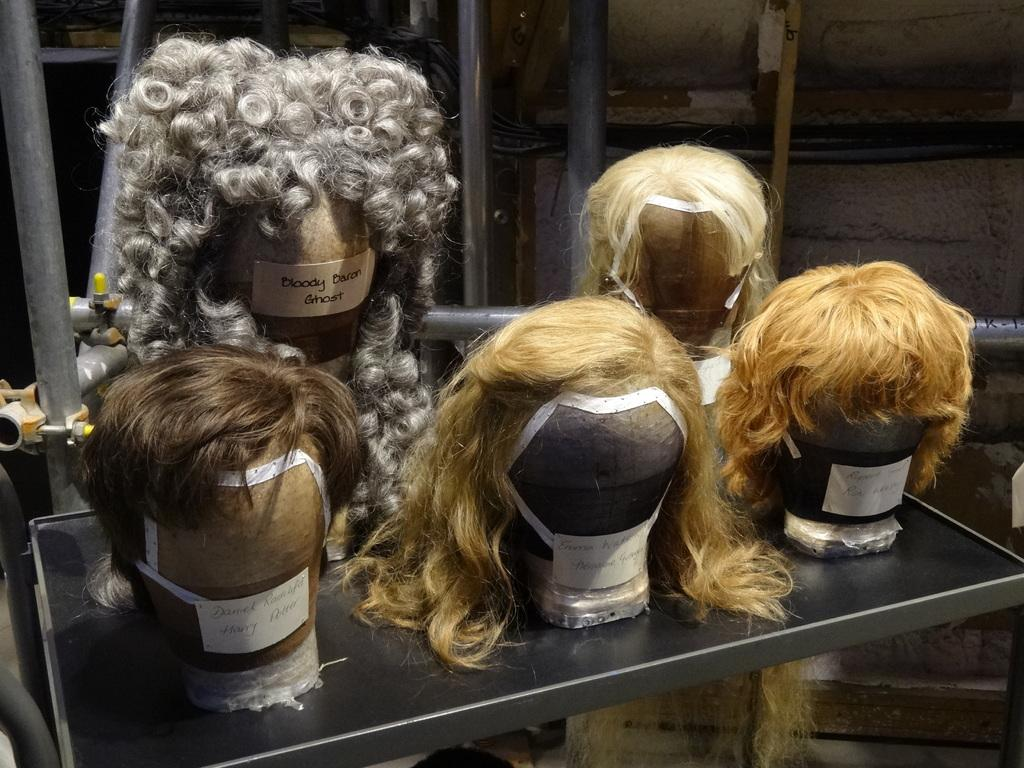What type of objects are in the image? There are wigs in the image. How many different colors can be seen on the wigs? The wigs are in different colors. Where are the wigs located? The wigs are on a table. What can be seen in the background of the image? There are poles and a wall visible in the background of the image. Can you see a railway in the image? No, there is no railway present in the image. Is the person's mom in the image? There is no person or mom mentioned or visible in the image. 